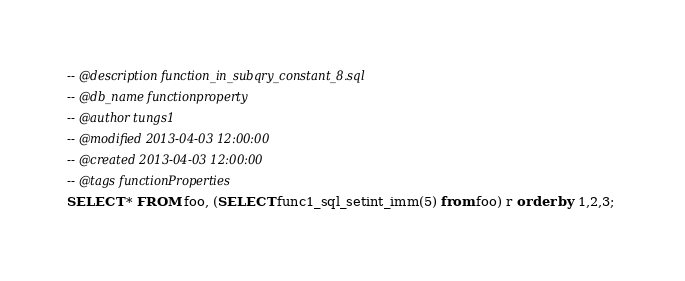<code> <loc_0><loc_0><loc_500><loc_500><_SQL_>-- @description function_in_subqry_constant_8.sql
-- @db_name functionproperty
-- @author tungs1
-- @modified 2013-04-03 12:00:00
-- @created 2013-04-03 12:00:00
-- @tags functionProperties 
SELECT * FROM foo, (SELECT func1_sql_setint_imm(5) from foo) r order by 1,2,3; 
</code> 